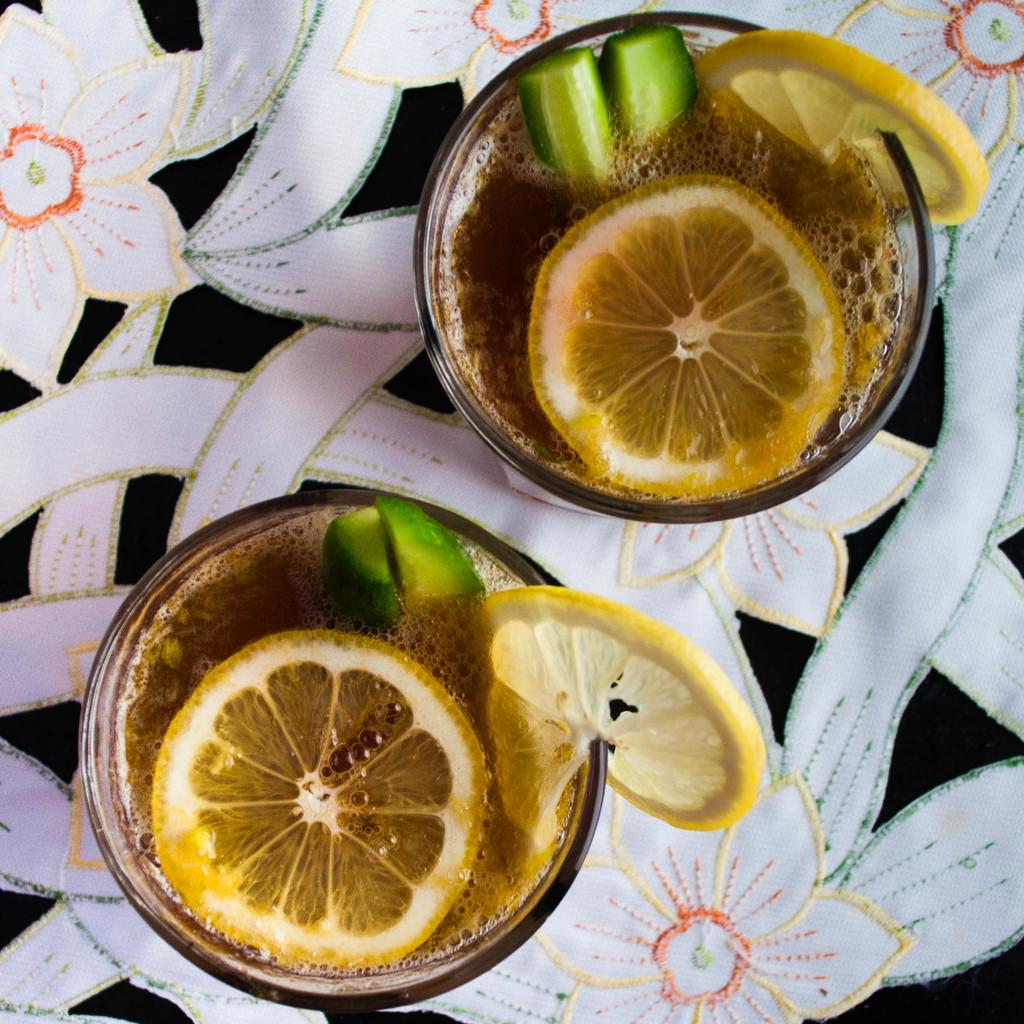What is in the bowls that are visible in the image? There are bowls with food in the image. Can you describe the colors of the food in the bowls? The food has brown, yellow, and green colors. What colors can be seen on the sheet where the bowls are placed? The sheet has white, black, and orange colors. How does the polish shine on the bowls in the image? There is no polish present in the image, and therefore no shine can be observed on the bowls. 